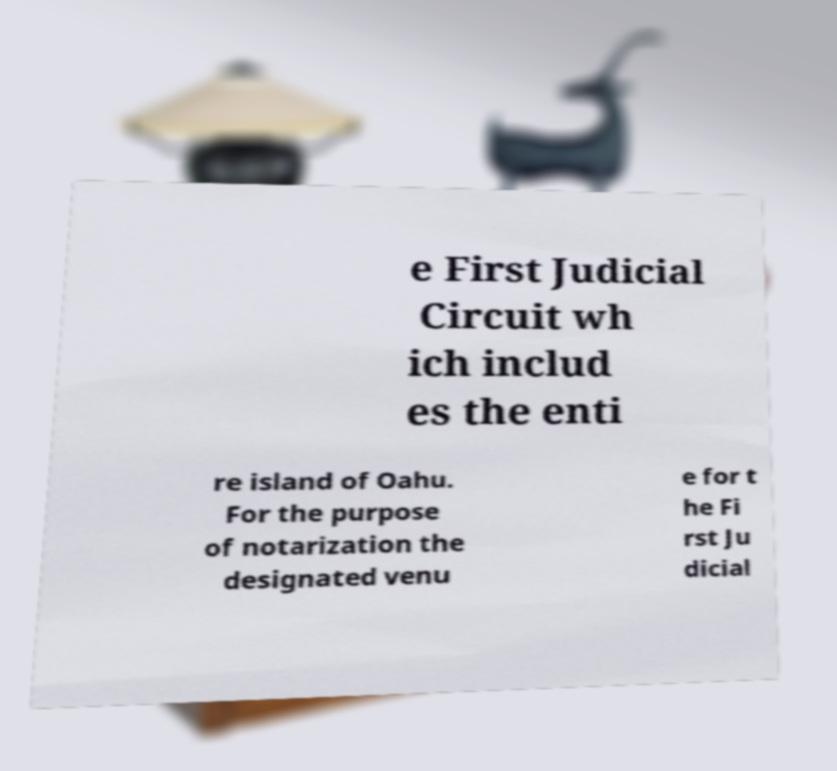Could you extract and type out the text from this image? e First Judicial Circuit wh ich includ es the enti re island of Oahu. For the purpose of notarization the designated venu e for t he Fi rst Ju dicial 